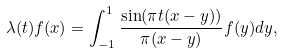Convert formula to latex. <formula><loc_0><loc_0><loc_500><loc_500>\lambda ( t ) f ( x ) = \int _ { - 1 } ^ { 1 } \frac { \sin ( \pi t ( x - y ) ) } { \pi ( x - y ) } f ( y ) d y ,</formula> 